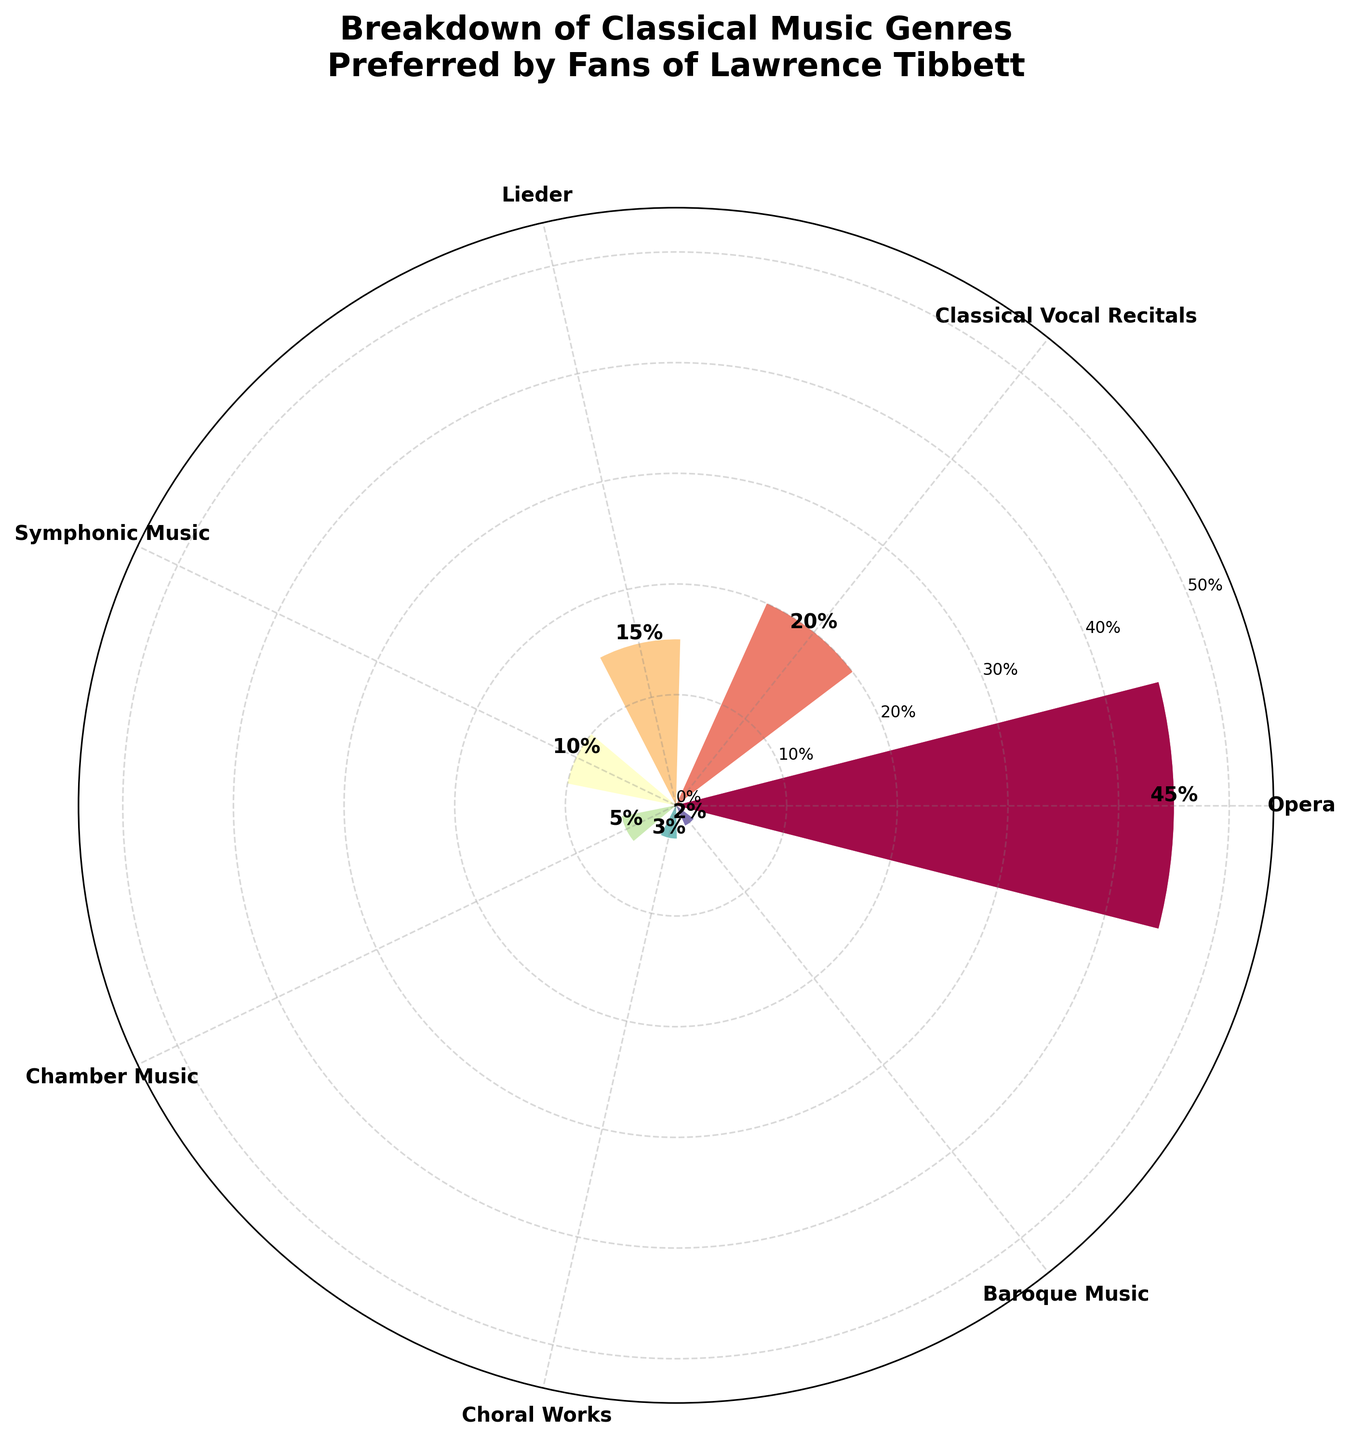What is the most preferred music genre by fans of Lawrence Tibbett? The genre with the highest percentage is the most preferred. By inspecting the plot, the longest bar, labeled with the highest percentage, represents the most preferred genre.
Answer: Opera What percentage of fans prefer Baroque Music? The specific segment labelled "Baroque Music" will have the percentage value clearly marked.
Answer: 2% What is the total percentage of fans who prefer Symphonic Music and Chamber Music combined? Add the percentages corresponding to "Symphonic Music" and "Chamber Music".
Answer: 15% Which genre has a lower preference than Symphonic Music but higher than Baroque Music? Compare percentages of genres in between 2% (Baroque Music) and 10% (Symphonic Music).
Answer: Chamber Music (5%) Which three genres make up the smallest combined percentage of preferences? Identify and sum the three smallest percentage values visible in the plot.
Answer: Choral Works, Baroque Music, and Chamber Music. (3 + 2 + 5 = 10%) How much more preferred is Classical Vocal Recitals compared to Lieder? Subtract the percentage of fans who prefer Lieder from those who prefer Classical Vocal Recitals.
Answer: 5% How much more preferred is Opera compared to Symphonic Music? Subtract the percentage of fans who prefer Symphonic Music from that of Opera.
Answer: 35% What's the combined preference percentage for all vocal-related genres (Opera, Classical Vocal Recitals, Lieder, Choral Works)? Identify the vocal-related genres and sum their percentages.
Answer: 45 + 20 + 15 + 3 = 83% What percent of fans prefer either Choral Works or Baroque Music? Add the percentages for Choral Works and Baroque Music.
Answer: 3 + 2 = 5% Rank the genres from most to least preferred. Order the genres by their respective percentages in descending order.
Answer: Opera, Classical Vocal Recitals, Lieder, Symphonic Music, Chamber Music, Choral Works, Baroque Music 